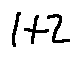Convert formula to latex. <formula><loc_0><loc_0><loc_500><loc_500>1 + 2</formula> 